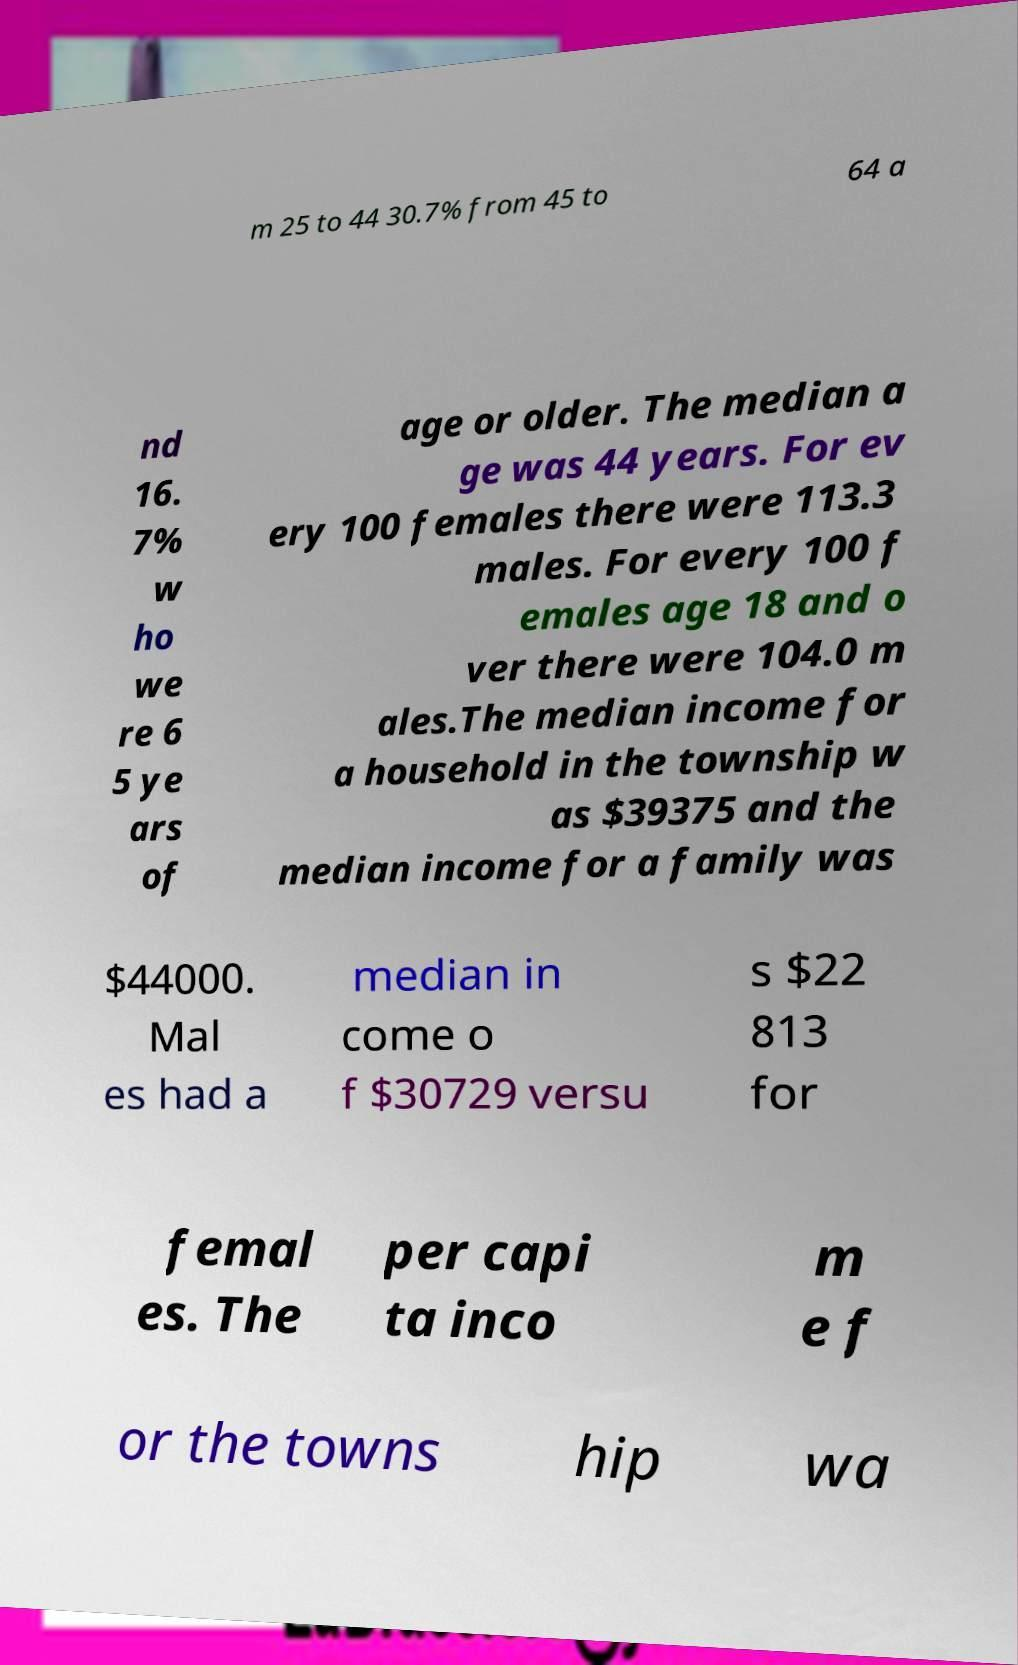For documentation purposes, I need the text within this image transcribed. Could you provide that? m 25 to 44 30.7% from 45 to 64 a nd 16. 7% w ho we re 6 5 ye ars of age or older. The median a ge was 44 years. For ev ery 100 females there were 113.3 males. For every 100 f emales age 18 and o ver there were 104.0 m ales.The median income for a household in the township w as $39375 and the median income for a family was $44000. Mal es had a median in come o f $30729 versu s $22 813 for femal es. The per capi ta inco m e f or the towns hip wa 